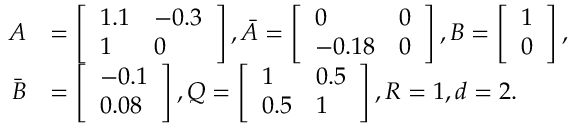<formula> <loc_0><loc_0><loc_500><loc_500>\begin{array} { r l } { A } & { = \left [ \begin{array} { l l } { 1 . 1 } & { - 0 . 3 } \\ { 1 } & { 0 } \end{array} \right ] , \bar { A } = \left [ \begin{array} { l l } { 0 } & { 0 } \\ { - 0 . 1 8 } & { 0 } \end{array} \right ] , B = \left [ \begin{array} { l } { 1 } \\ { 0 } \end{array} \right ] , } \\ { \bar { B } } & { = \left [ \begin{array} { l } { - 0 . 1 } \\ { 0 . 0 8 } \end{array} \right ] , Q = \left [ \begin{array} { l l } { 1 } & { 0 . 5 } \\ { 0 . 5 } & { 1 } \end{array} \right ] , R = 1 , d = 2 . } \end{array}</formula> 